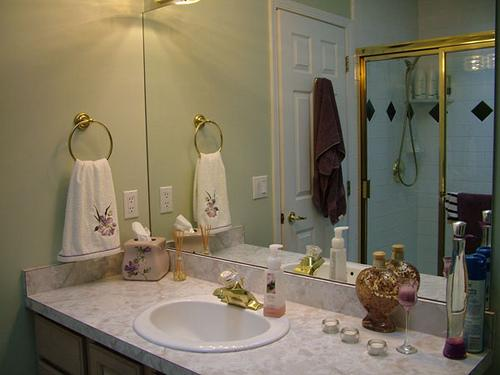What is closest to the place you would go to charge your phone? Please explain your reasoning. white towel. There is an electrical outlet beside the hand towel. 